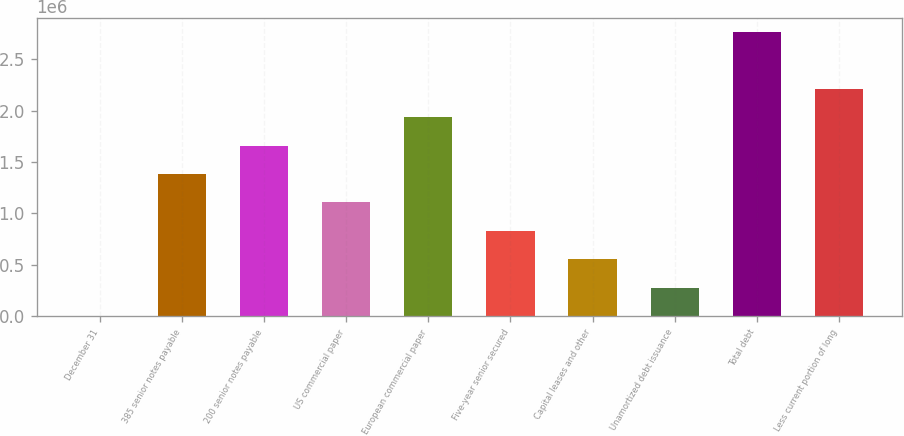Convert chart. <chart><loc_0><loc_0><loc_500><loc_500><bar_chart><fcel>December 31<fcel>385 senior notes payable<fcel>200 senior notes payable<fcel>US commercial paper<fcel>European commercial paper<fcel>Five-year senior secured<fcel>Capital leases and other<fcel>Unamortized debt issuance<fcel>Total debt<fcel>Less current portion of long<nl><fcel>2017<fcel>1.3828e+06<fcel>1.65895e+06<fcel>1.10664e+06<fcel>1.93511e+06<fcel>830485<fcel>554329<fcel>278173<fcel>2.76358e+06<fcel>2.21127e+06<nl></chart> 